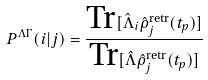Convert formula to latex. <formula><loc_0><loc_0><loc_500><loc_500>P ^ { \Lambda \Gamma } ( i | j ) = \frac { \text {Tr} [ \hat { \Lambda } _ { i } \hat { \rho } ^ { \text {retr} } _ { j } ( t _ { p } ) ] } { \text {Tr} [ \hat { \Lambda } \hat { \rho } ^ { \text {retr} } _ { j } ( t _ { p } ) ] }</formula> 